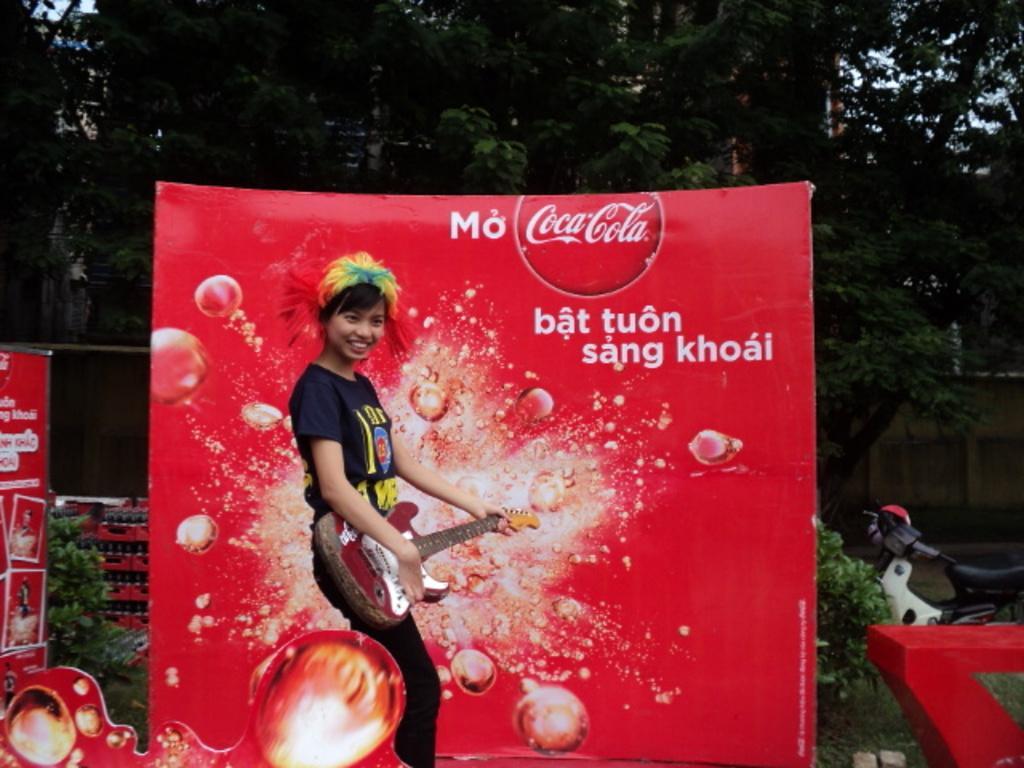Could you give a brief overview of what you see in this image? In this image there is a person holding a guitar. She is standing. Behind there is a banner having some text on it. Left side there are baskets having bottles. Before it there are plants. Left side there is a banner. Right side there is an object. Behind there is a plant. There is a vehicle. Background there are trees behind there are buildings. 